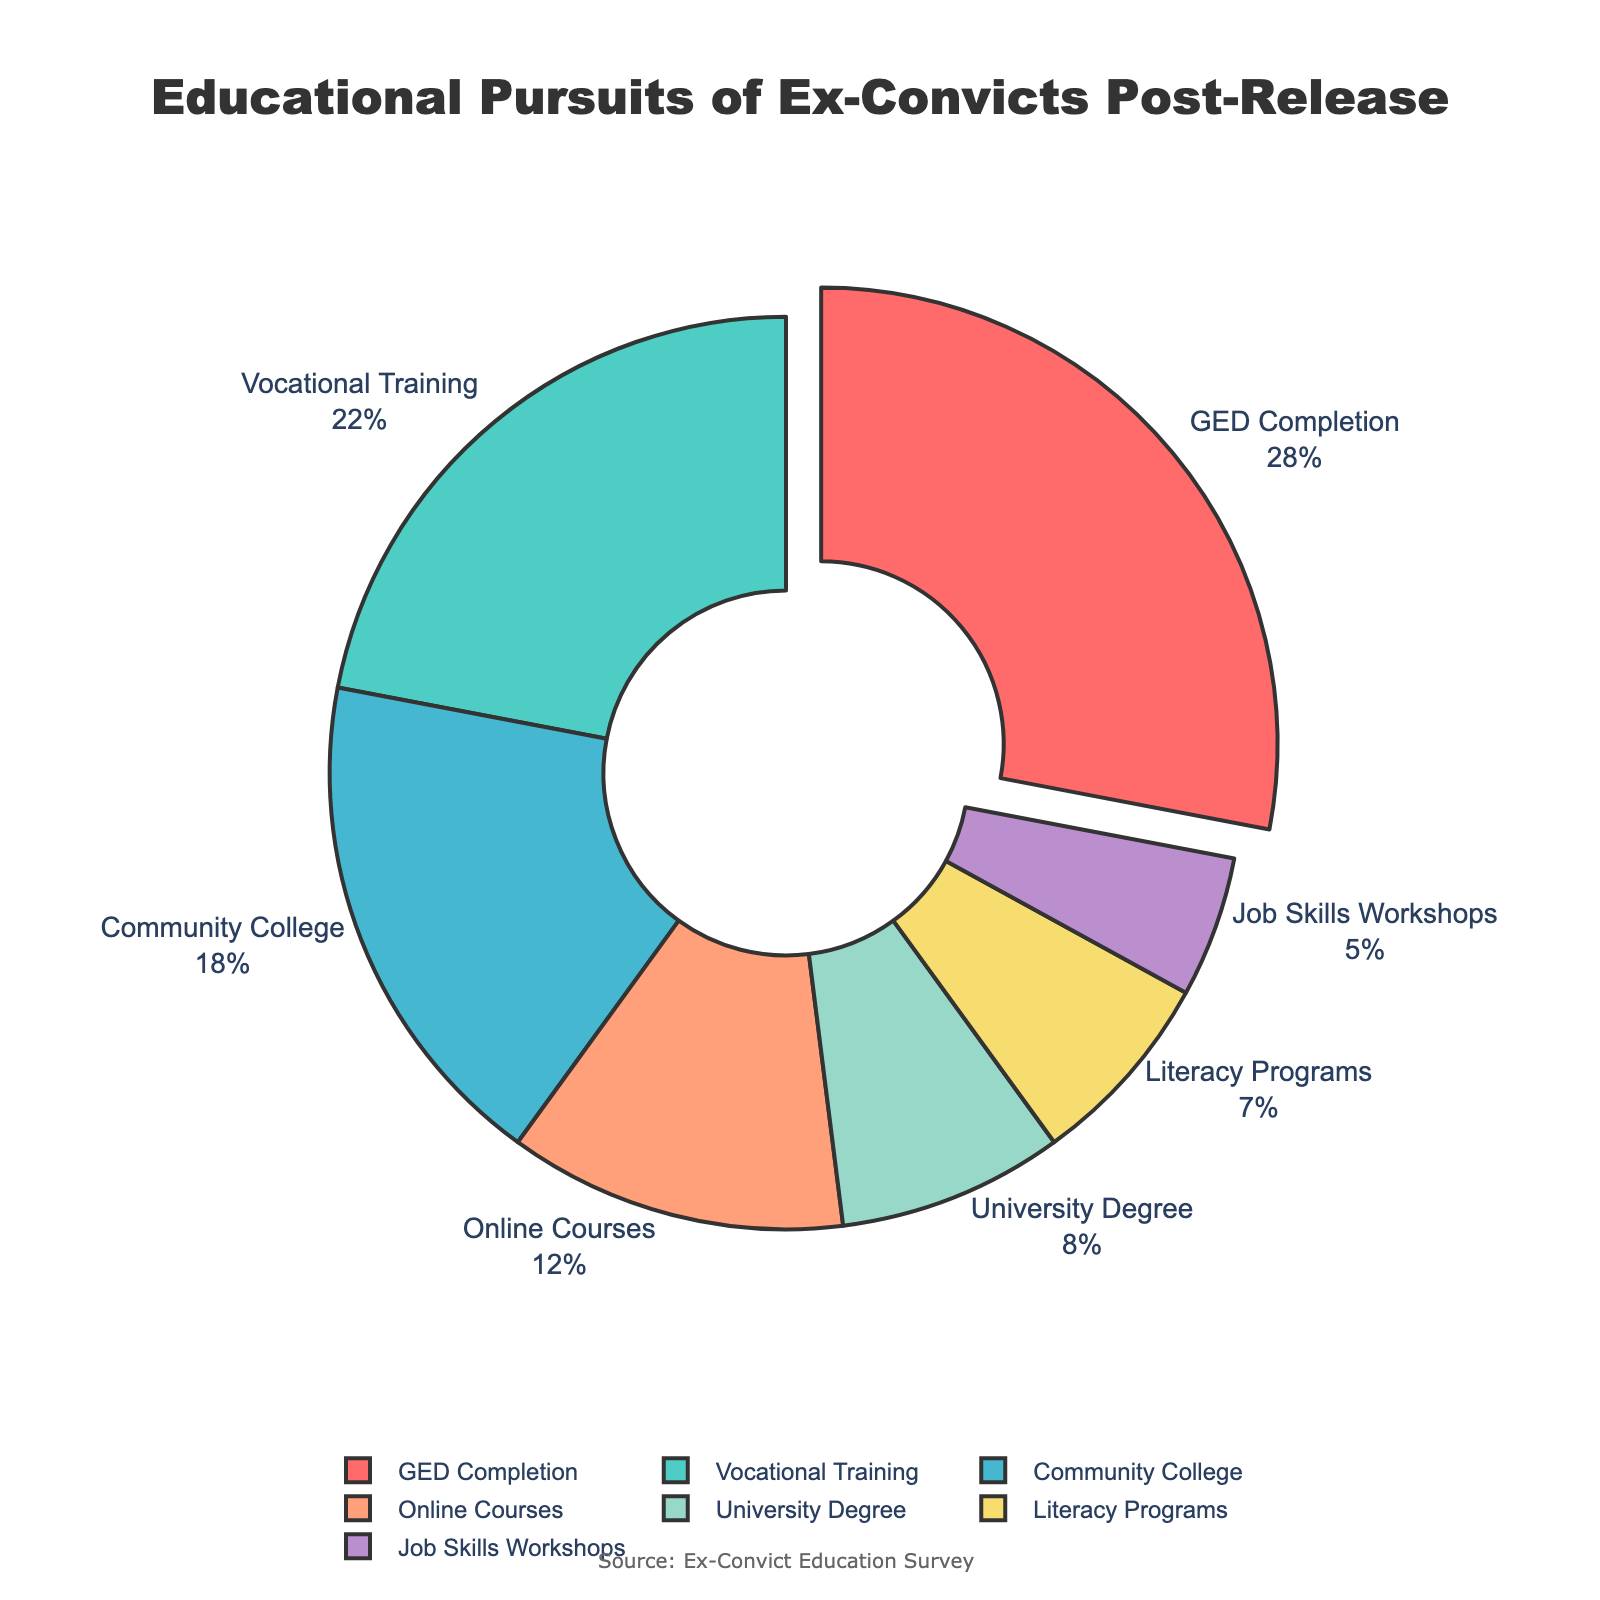What is the most common educational pursuit among ex-convicts post-release? The largest segment in the pie chart represents the most common pursuit. By observing the visual, "GED Completion" has the largest share with 28%.
Answer: GED Completion Which educational pursuit has the smallest percentage? The smallest segment in the pie chart represents the educational pursuit with the lowest percentage. "Job Skills Workshops" has the smallest share with 5%.
Answer: Job Skills Workshops What is the total percentage of ex-convicts participating in GED Completion and Vocational Training? Add the percentages of "GED Completion" and "Vocational Training". GED Completion (28%) + Vocational Training (22%) = 50%.
Answer: 50% How does the percentage of university degree pursuit compare to community college enrollment? Compare the percentages of "University Degree" and "Community College". University Degree (8%) is less than Community College (18%)
Answer: University Degree is less What proportion of ex-convicts engages in online courses? The pie chart shows the percentage of each educational pursuit, with "Online Courses" being 12%.
Answer: 12% What is the combined percentage of ex-convicts in literacy programs and job skills workshops? Add the percentages of "Literacy Programs" and "Job Skills Workshops". Literacy Programs (7%) + Job Skills Workshops (5%) = 12%.
Answer: 12% Which three educational pursuits have percentages less than 10%? Identify segments with percentages less than 10%. "University Degree" (8%), "Literacy Programs" (7%), and "Job Skills Workshops" (5%) are less than 10%.
Answer: University Degree, Literacy Programs, Job Skills Workshops If you combined community college and university degree, what would be their total percentage? Add the percentages of "Community College" and "University Degree". Community College (18%) + University Degree (8%) = 26%.
Answer: 26% Which pursuit is represented by a larger segment: Literacy Programs or Online Courses? Compare the segments of "Literacy Programs" and "Online Courses". Online Courses (12%) has a larger segment than Literacy Programs (7%).
Answer: Online Courses Does vocational training have a larger share than online courses? Compare the segments of "Vocational Training" and "Online Courses". Vocational Training (22%) has a larger share than Online Courses (12%).
Answer: Yes 